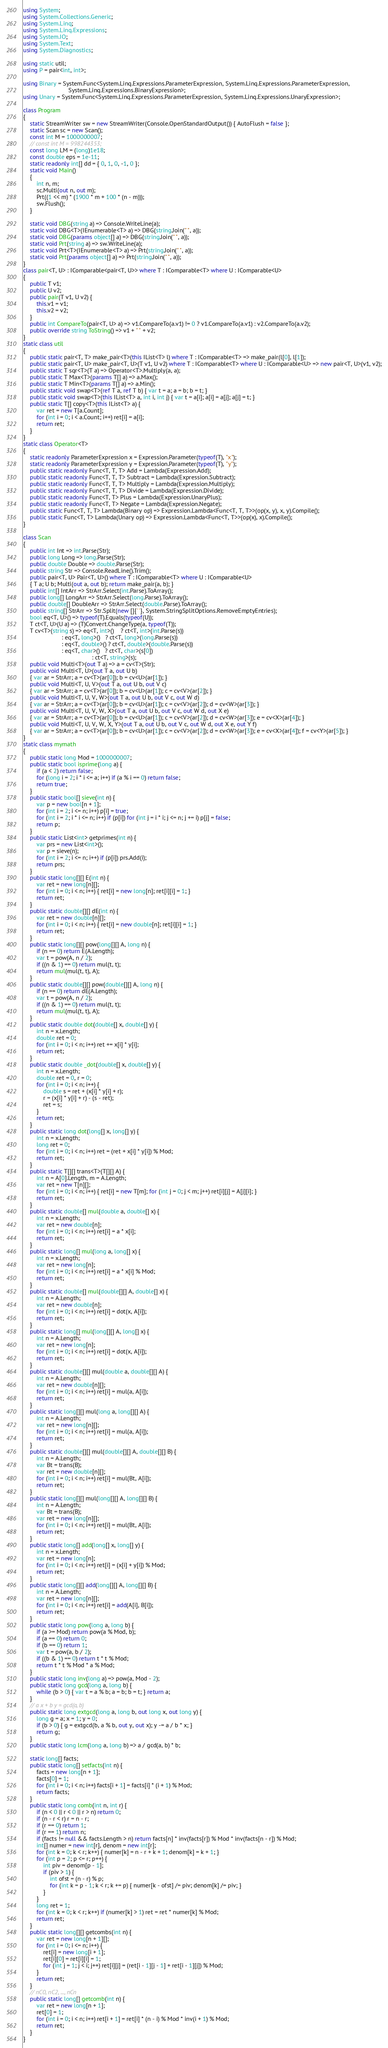Convert code to text. <code><loc_0><loc_0><loc_500><loc_500><_C#_>using System;
using System.Collections.Generic;
using System.Linq;
using System.Linq.Expressions;
using System.IO;
using System.Text;
using System.Diagnostics;

using static util;
using P = pair<int, int>;

using Binary = System.Func<System.Linq.Expressions.ParameterExpression, System.Linq.Expressions.ParameterExpression,
                           System.Linq.Expressions.BinaryExpression>;
using Unary = System.Func<System.Linq.Expressions.ParameterExpression, System.Linq.Expressions.UnaryExpression>;

class Program
{
    static StreamWriter sw = new StreamWriter(Console.OpenStandardOutput()) { AutoFlush = false };
    static Scan sc = new Scan();
    const int M = 1000000007;
    // const int M = 998244353;
    const long LM = (long)1e18;
    const double eps = 1e-11;
    static readonly int[] dd = { 0, 1, 0, -1, 0 };
    static void Main()
    {
        int n, m;
        sc.Multi(out n, out m);
        Prt((1 << m) * (1900 * m + 100 * (n - m)));
        sw.Flush();
    }

    static void DBG(string a) => Console.WriteLine(a);
    static void DBG<T>(IEnumerable<T> a) => DBG(string.Join(" ", a));
    static void DBG(params object[] a) => DBG(string.Join(" ", a));
    static void Prt(string a) => sw.WriteLine(a);
    static void Prt<T>(IEnumerable<T> a) => Prt(string.Join(" ", a));
    static void Prt(params object[] a) => Prt(string.Join(" ", a));
}
class pair<T, U> : IComparable<pair<T, U>> where T : IComparable<T> where U : IComparable<U>
{
    public T v1;
    public U v2;
    public pair(T v1, U v2) {
        this.v1 = v1;
        this.v2 = v2;
    }
    public int CompareTo(pair<T, U> a) => v1.CompareTo(a.v1) != 0 ? v1.CompareTo(a.v1) : v2.CompareTo(a.v2);
    public override string ToString() => v1 + " " + v2;
}
static class util
{
    public static pair<T, T> make_pair<T>(this IList<T> l) where T : IComparable<T> => make_pair(l[0], l[1]);
    public static pair<T, U> make_pair<T, U>(T v1, U v2) where T : IComparable<T> where U : IComparable<U> => new pair<T, U>(v1, v2);
    public static T sqr<T>(T a) => Operator<T>.Multiply(a, a);
    public static T Max<T>(params T[] a) => a.Max();
    public static T Min<T>(params T[] a) => a.Min();
    public static void swap<T>(ref T a, ref T b) { var t = a; a = b; b = t; }
    public static void swap<T>(this IList<T> a, int i, int j) { var t = a[i]; a[i] = a[j]; a[j] = t; }
    public static T[] copy<T>(this IList<T> a) {
        var ret = new T[a.Count];
        for (int i = 0; i < a.Count; i++) ret[i] = a[i];
        return ret;
    }
}
static class Operator<T>
{
    static readonly ParameterExpression x = Expression.Parameter(typeof(T), "x");
    static readonly ParameterExpression y = Expression.Parameter(typeof(T), "y");
    public static readonly Func<T, T, T> Add = Lambda(Expression.Add);
    public static readonly Func<T, T, T> Subtract = Lambda(Expression.Subtract);
    public static readonly Func<T, T, T> Multiply = Lambda(Expression.Multiply);
    public static readonly Func<T, T, T> Divide = Lambda(Expression.Divide);
    public static readonly Func<T, T> Plus = Lambda(Expression.UnaryPlus);
    public static readonly Func<T, T> Negate = Lambda(Expression.Negate);
    public static Func<T, T, T> Lambda(Binary op) => Expression.Lambda<Func<T, T, T>>(op(x, y), x, y).Compile();
    public static Func<T, T> Lambda(Unary op) => Expression.Lambda<Func<T, T>>(op(x), x).Compile();
}

class Scan
{
    public int Int => int.Parse(Str);
    public long Long => long.Parse(Str);
    public double Double => double.Parse(Str);
    public string Str => Console.ReadLine().Trim();
    public pair<T, U> Pair<T, U>() where T : IComparable<T> where U : IComparable<U>
    { T a; U b; Multi(out a, out b); return make_pair(a, b); }
    public int[] IntArr => StrArr.Select(int.Parse).ToArray();
    public long[] LongArr => StrArr.Select(long.Parse).ToArray();
    public double[] DoubleArr => StrArr.Select(double.Parse).ToArray();
    public string[] StrArr => Str.Split(new []{' '}, System.StringSplitOptions.RemoveEmptyEntries);
    bool eq<T, U>() => typeof(T).Equals(typeof(U));
    T ct<T, U>(U a) => (T)Convert.ChangeType(a, typeof(T));
    T cv<T>(string s) => eq<T, int>()    ? ct<T, int>(int.Parse(s))
                       : eq<T, long>()   ? ct<T, long>(long.Parse(s))
                       : eq<T, double>() ? ct<T, double>(double.Parse(s))
                       : eq<T, char>()   ? ct<T, char>(s[0])
                                         : ct<T, string>(s);
    public void Multi<T>(out T a) => a = cv<T>(Str);
    public void Multi<T, U>(out T a, out U b)
    { var ar = StrArr; a = cv<T>(ar[0]); b = cv<U>(ar[1]); }
    public void Multi<T, U, V>(out T a, out U b, out V c)
    { var ar = StrArr; a = cv<T>(ar[0]); b = cv<U>(ar[1]); c = cv<V>(ar[2]); }
    public void Multi<T, U, V, W>(out T a, out U b, out V c, out W d)
    { var ar = StrArr; a = cv<T>(ar[0]); b = cv<U>(ar[1]); c = cv<V>(ar[2]); d = cv<W>(ar[3]); }
    public void Multi<T, U, V, W, X>(out T a, out U b, out V c, out W d, out X e)
    { var ar = StrArr; a = cv<T>(ar[0]); b = cv<U>(ar[1]); c = cv<V>(ar[2]); d = cv<W>(ar[3]); e = cv<X>(ar[4]); }
    public void Multi<T, U, V, W, X, Y>(out T a, out U b, out V c, out W d, out X e, out Y f)
    { var ar = StrArr; a = cv<T>(ar[0]); b = cv<U>(ar[1]); c = cv<V>(ar[2]); d = cv<W>(ar[3]); e = cv<X>(ar[4]); f = cv<Y>(ar[5]); }
}
static class mymath
{
    public static long Mod = 1000000007;
    public static bool isprime(long a) {
        if (a < 2) return false;
        for (long i = 2; i * i <= a; i++) if (a % i == 0) return false;
        return true;
    }
    public static bool[] sieve(int n) {
        var p = new bool[n + 1];
        for (int i = 2; i <= n; i++) p[i] = true;
        for (int i = 2; i * i <= n; i++) if (p[i]) for (int j = i * i; j <= n; j += i) p[j] = false;
        return p;
    }
    public static List<int> getprimes(int n) {
        var prs = new List<int>();
        var p = sieve(n);
        for (int i = 2; i <= n; i++) if (p[i]) prs.Add(i);
        return prs;
    }
    public static long[][] E(int n) {
        var ret = new long[n][];
        for (int i = 0; i < n; i++) { ret[i] = new long[n]; ret[i][i] = 1; }
        return ret;
    }
    public static double[][] dE(int n) {
        var ret = new double[n][];
        for (int i = 0; i < n; i++) { ret[i] = new double[n]; ret[i][i] = 1; }
        return ret;
    }
    public static long[][] pow(long[][] A, long n) {
        if (n == 0) return E(A.Length);
        var t = pow(A, n / 2);
        if ((n & 1) == 0) return mul(t, t);
        return mul(mul(t, t), A);
    }
    public static double[][] pow(double[][] A, long n) {
        if (n == 0) return dE(A.Length);
        var t = pow(A, n / 2);
        if ((n & 1) == 0) return mul(t, t);
        return mul(mul(t, t), A);
    }
    public static double dot(double[] x, double[] y) {
        int n = x.Length;
        double ret = 0;
        for (int i = 0; i < n; i++) ret += x[i] * y[i];
        return ret;
    }
    public static double _dot(double[] x, double[] y) {
        int n = x.Length;
        double ret = 0, r = 0;
        for (int i = 0; i < n; i++) {
            double s = ret + (x[i] * y[i] + r);
            r = (x[i] * y[i] + r) - (s - ret);
            ret = s;
        }
        return ret;
    }
    public static long dot(long[] x, long[] y) {
        int n = x.Length;
        long ret = 0;
        for (int i = 0; i < n; i++) ret = (ret + x[i] * y[i]) % Mod;
        return ret;
    }
    public static T[][] trans<T>(T[][] A) {
        int n = A[0].Length, m = A.Length;
        var ret = new T[n][];
        for (int i = 0; i < n; i++) { ret[i] = new T[m]; for (int j = 0; j < m; j++) ret[i][j] = A[j][i]; }
        return ret;
    }
    public static double[] mul(double a, double[] x) {
        int n = x.Length;
        var ret = new double[n];
        for (int i = 0; i < n; i++) ret[i] = a * x[i];
        return ret;
    }
    public static long[] mul(long a, long[] x) {
        int n = x.Length;
        var ret = new long[n];
        for (int i = 0; i < n; i++) ret[i] = a * x[i] % Mod;
        return ret;
    }
    public static double[] mul(double[][] A, double[] x) {
        int n = A.Length;
        var ret = new double[n];
        for (int i = 0; i < n; i++) ret[i] = dot(x, A[i]);
        return ret;
    }
    public static long[] mul(long[][] A, long[] x) {
        int n = A.Length;
        var ret = new long[n];
        for (int i = 0; i < n; i++) ret[i] = dot(x, A[i]);
        return ret;
    }
    public static double[][] mul(double a, double[][] A) {
        int n = A.Length;
        var ret = new double[n][];
        for (int i = 0; i < n; i++) ret[i] = mul(a, A[i]);
        return ret;
    }
    public static long[][] mul(long a, long[][] A) {
        int n = A.Length;
        var ret = new long[n][];
        for (int i = 0; i < n; i++) ret[i] = mul(a, A[i]);
        return ret;
    }
    public static double[][] mul(double[][] A, double[][] B) {
        int n = A.Length;
        var Bt = trans(B);
        var ret = new double[n][];
        for (int i = 0; i < n; i++) ret[i] = mul(Bt, A[i]);
        return ret;
    }
    public static long[][] mul(long[][] A, long[][] B) {
        int n = A.Length;
        var Bt = trans(B);
        var ret = new long[n][];
        for (int i = 0; i < n; i++) ret[i] = mul(Bt, A[i]);
        return ret;
    }
    public static long[] add(long[] x, long[] y) {
        int n = x.Length;
        var ret = new long[n];
        for (int i = 0; i < n; i++) ret[i] = (x[i] + y[i]) % Mod;
        return ret;
    }
    public static long[][] add(long[][] A, long[][] B) {
        int n = A.Length;
        var ret = new long[n][];
        for (int i = 0; i < n; i++) ret[i] = add(A[i], B[i]);
        return ret;
    }
    public static long pow(long a, long b) {
        if (a >= Mod) return pow(a % Mod, b);
        if (a == 0) return 0;
        if (b == 0) return 1;
        var t = pow(a, b / 2);
        if ((b & 1) == 0) return t * t % Mod;
        return t * t % Mod * a % Mod;
    }
    public static long inv(long a) => pow(a, Mod - 2);
    public static long gcd(long a, long b) {
        while (b > 0) { var t = a % b; a = b; b = t; } return a;
    }
    // a x + b y = gcd(a, b)
    public static long extgcd(long a, long b, out long x, out long y) {
        long g = a; x = 1; y = 0;
        if (b > 0) { g = extgcd(b, a % b, out y, out x); y -= a / b * x; }
        return g;
    }
    public static long lcm(long a, long b) => a / gcd(a, b) * b;

    static long[] facts;
    public static long[] setfacts(int n) {
        facts = new long[n + 1];
        facts[0] = 1;
        for (int i = 0; i < n; i++) facts[i + 1] = facts[i] * (i + 1) % Mod;
        return facts;
    }
    public static long comb(int n, int r) {
        if (n < 0 || r < 0 || r > n) return 0;
        if (n - r < r) r = n - r;
        if (r == 0) return 1;
        if (r == 1) return n;
        if (facts != null && facts.Length > n) return facts[n] * inv(facts[r]) % Mod * inv(facts[n - r]) % Mod;
        int[] numer = new int[r], denom = new int[r];
        for (int k = 0; k < r; k++) { numer[k] = n - r + k + 1; denom[k] = k + 1; }
        for (int p = 2; p <= r; p++) {
            int piv = denom[p - 1];
            if (piv > 1) {
                int ofst = (n - r) % p;
                for (int k = p - 1; k < r; k += p) { numer[k - ofst] /= piv; denom[k] /= piv; }
            }
        }
        long ret = 1;
        for (int k = 0; k < r; k++) if (numer[k] > 1) ret = ret * numer[k] % Mod;
        return ret;
    }
    public static long[][] getcombs(int n) {
        var ret = new long[n + 1][];
        for (int i = 0; i <= n; i++) {
            ret[i] = new long[i + 1];
            ret[i][0] = ret[i][i] = 1;
            for (int j = 1; j < i; j++) ret[i][j] = (ret[i - 1][j - 1] + ret[i - 1][j]) % Mod;
        }
        return ret;
    }
    // nC0, nC2, ..., nCn
    public static long[] getcomb(int n) {
        var ret = new long[n + 1];
        ret[0] = 1;
        for (int i = 0; i < n; i++) ret[i + 1] = ret[i] * (n - i) % Mod * inv(i + 1) % Mod;
        return ret;
    }
}
</code> 